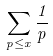<formula> <loc_0><loc_0><loc_500><loc_500>\sum _ { p \leq x } \frac { 1 } { p }</formula> 